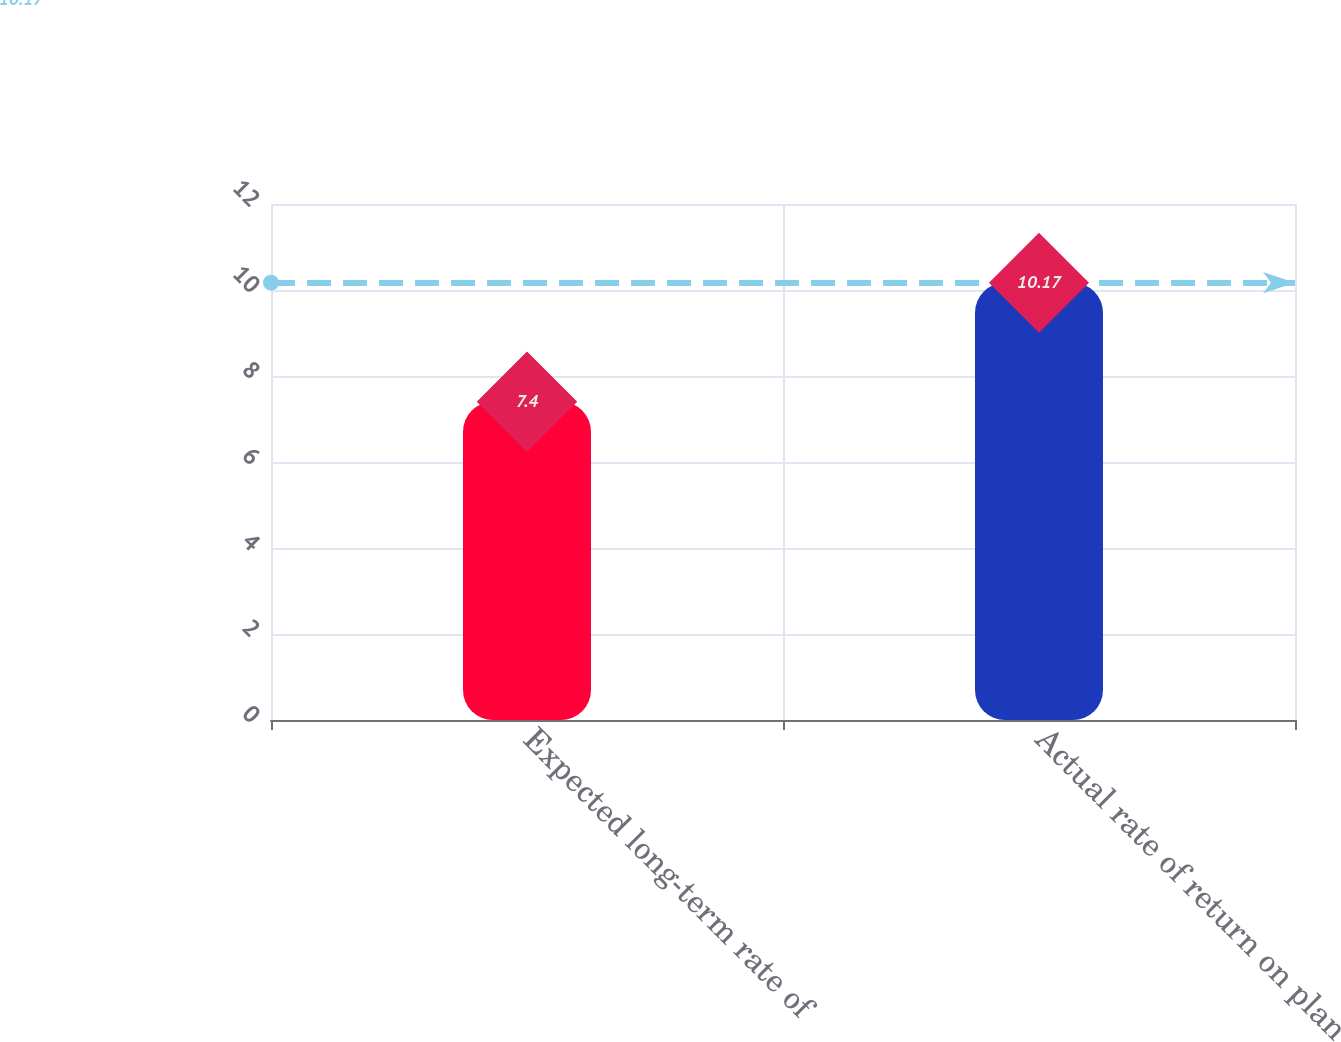Convert chart. <chart><loc_0><loc_0><loc_500><loc_500><bar_chart><fcel>Expected long-term rate of<fcel>Actual rate of return on plan<nl><fcel>7.4<fcel>10.17<nl></chart> 